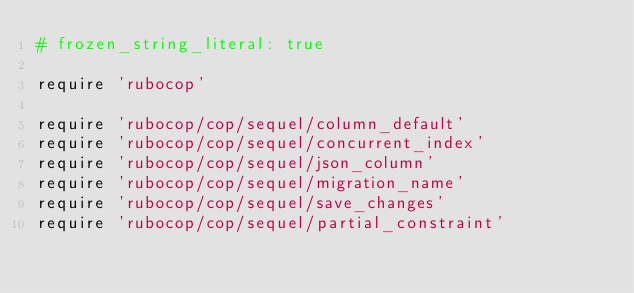<code> <loc_0><loc_0><loc_500><loc_500><_Ruby_># frozen_string_literal: true

require 'rubocop'

require 'rubocop/cop/sequel/column_default'
require 'rubocop/cop/sequel/concurrent_index'
require 'rubocop/cop/sequel/json_column'
require 'rubocop/cop/sequel/migration_name'
require 'rubocop/cop/sequel/save_changes'
require 'rubocop/cop/sequel/partial_constraint'
</code> 